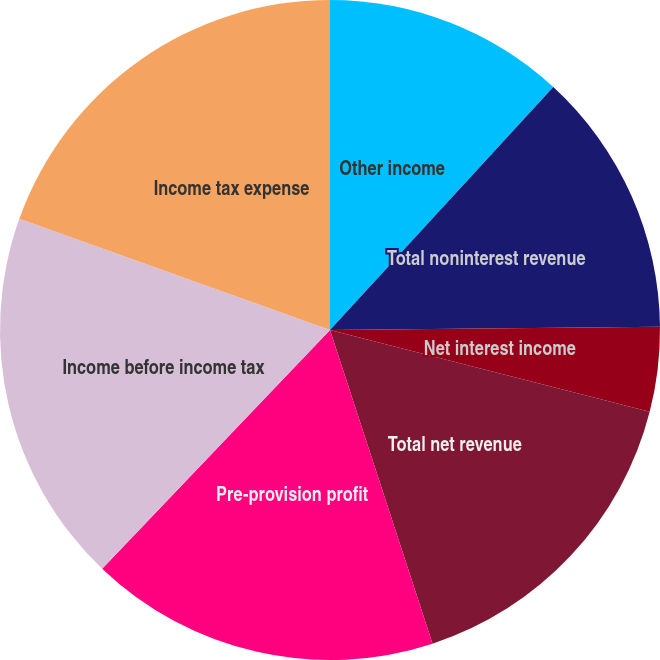Convert chart. <chart><loc_0><loc_0><loc_500><loc_500><pie_chart><fcel>Other income<fcel>Total noninterest revenue<fcel>Net interest income<fcel>Total net revenue<fcel>Pre-provision profit<fcel>Income before income tax<fcel>Income tax expense<nl><fcel>11.83%<fcel>13.01%<fcel>4.15%<fcel>15.98%<fcel>17.16%<fcel>18.34%<fcel>19.53%<nl></chart> 